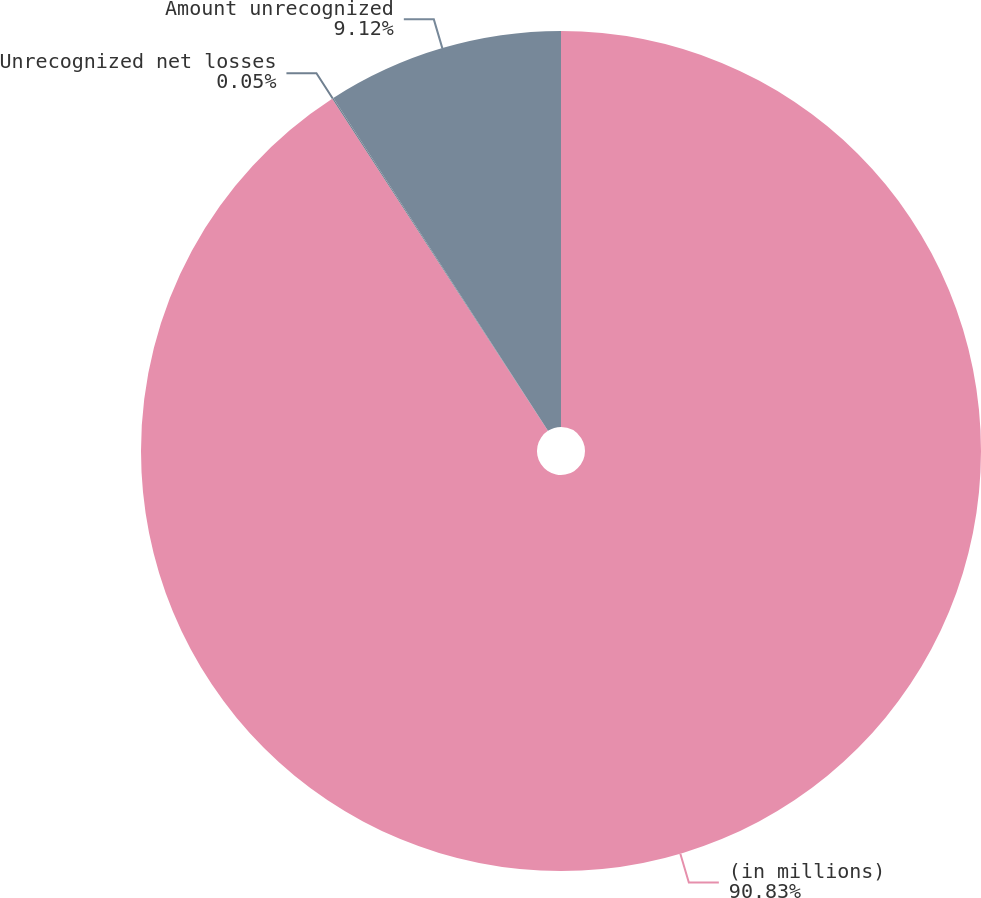<chart> <loc_0><loc_0><loc_500><loc_500><pie_chart><fcel>(in millions)<fcel>Unrecognized net losses<fcel>Amount unrecognized<nl><fcel>90.83%<fcel>0.05%<fcel>9.12%<nl></chart> 